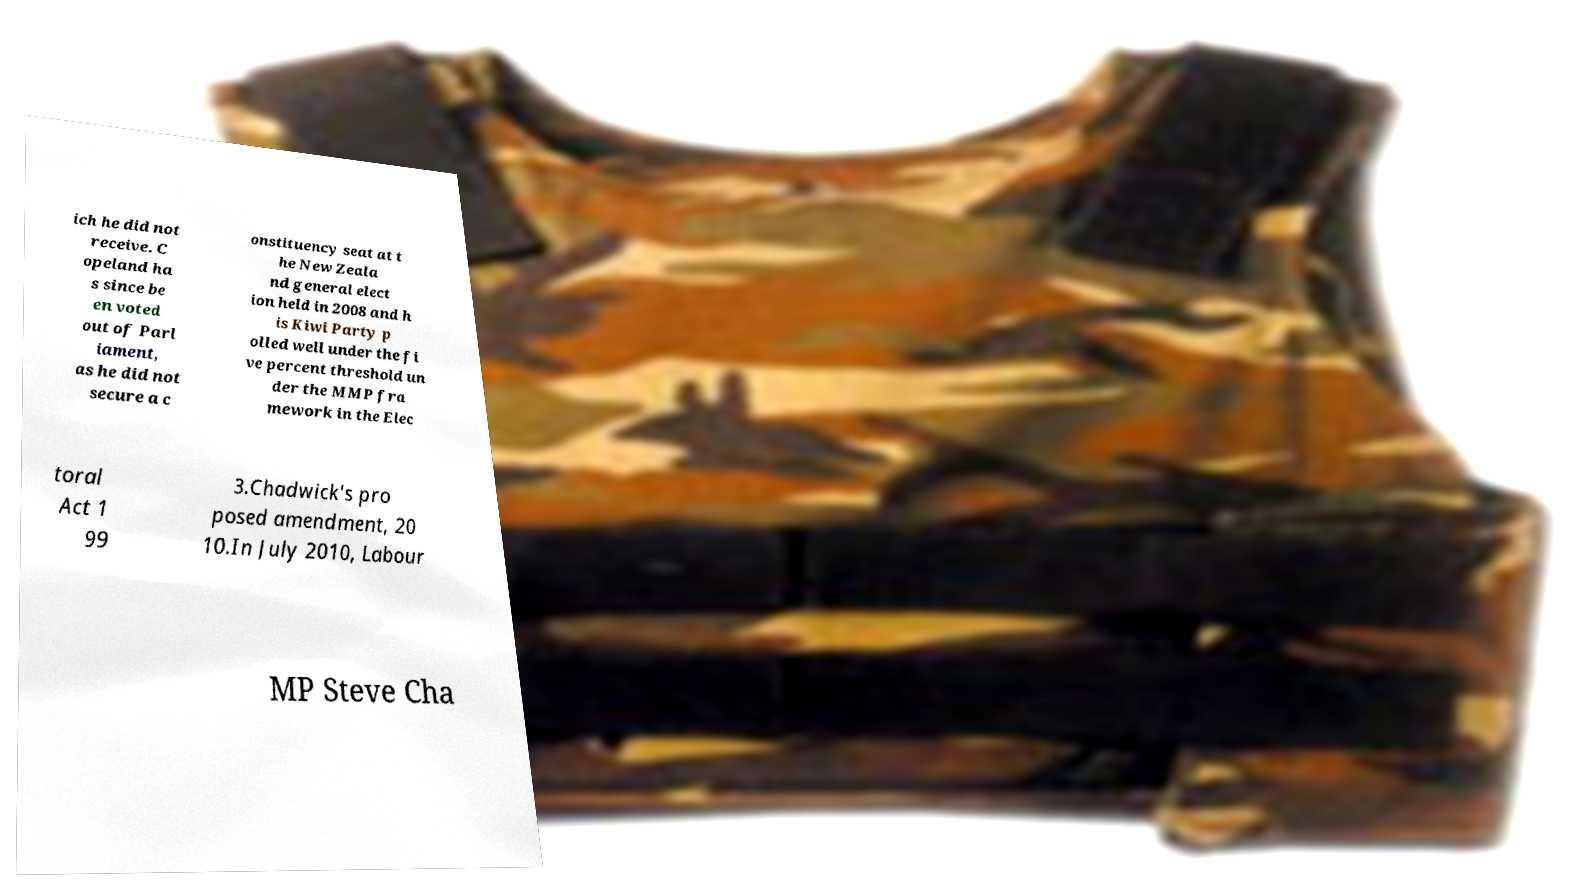What messages or text are displayed in this image? I need them in a readable, typed format. ich he did not receive. C opeland ha s since be en voted out of Parl iament, as he did not secure a c onstituency seat at t he New Zeala nd general elect ion held in 2008 and h is Kiwi Party p olled well under the fi ve percent threshold un der the MMP fra mework in the Elec toral Act 1 99 3.Chadwick's pro posed amendment, 20 10.In July 2010, Labour MP Steve Cha 